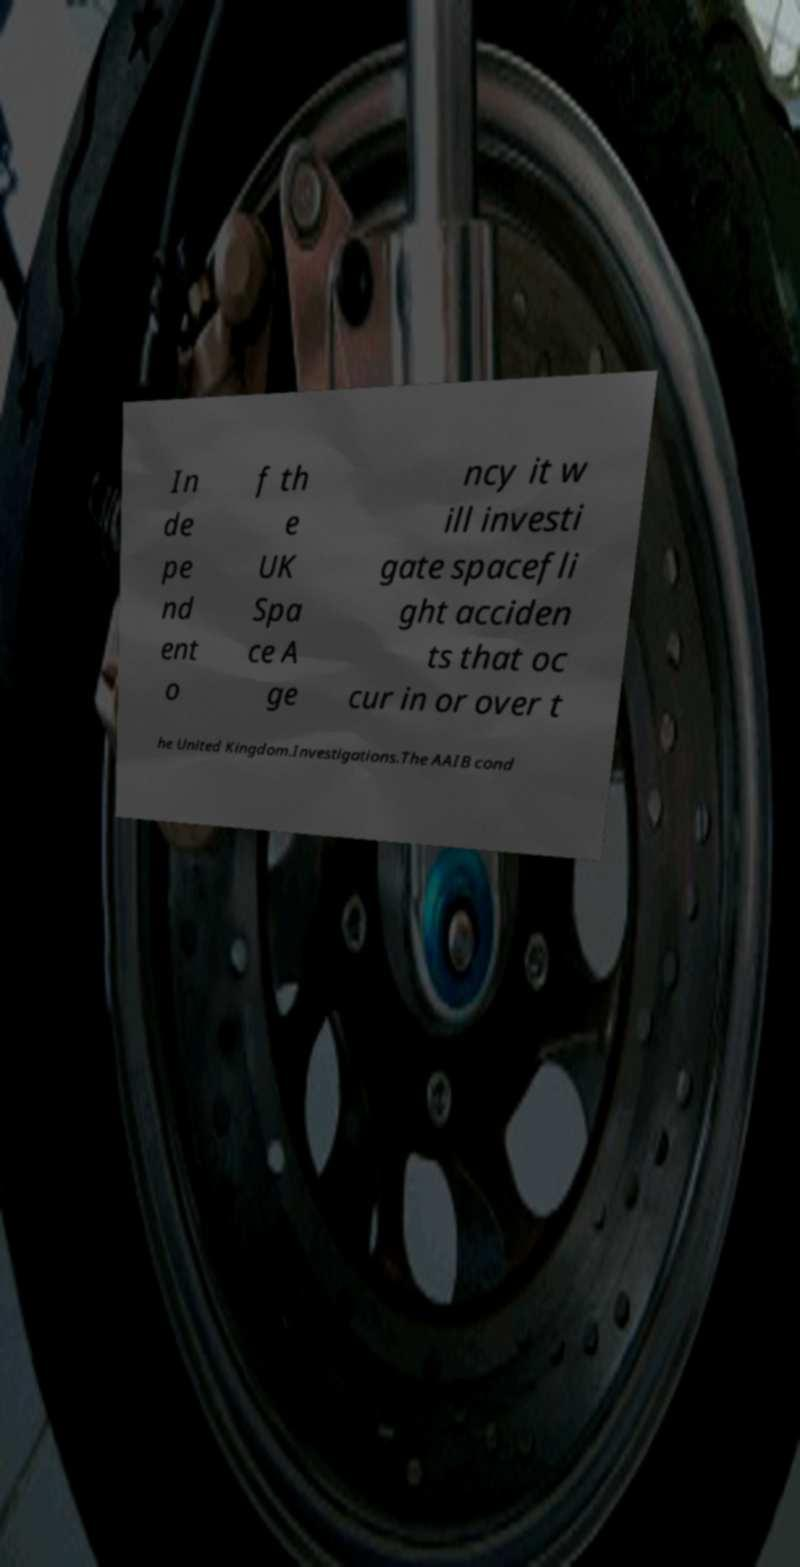For documentation purposes, I need the text within this image transcribed. Could you provide that? In de pe nd ent o f th e UK Spa ce A ge ncy it w ill investi gate spacefli ght acciden ts that oc cur in or over t he United Kingdom.Investigations.The AAIB cond 